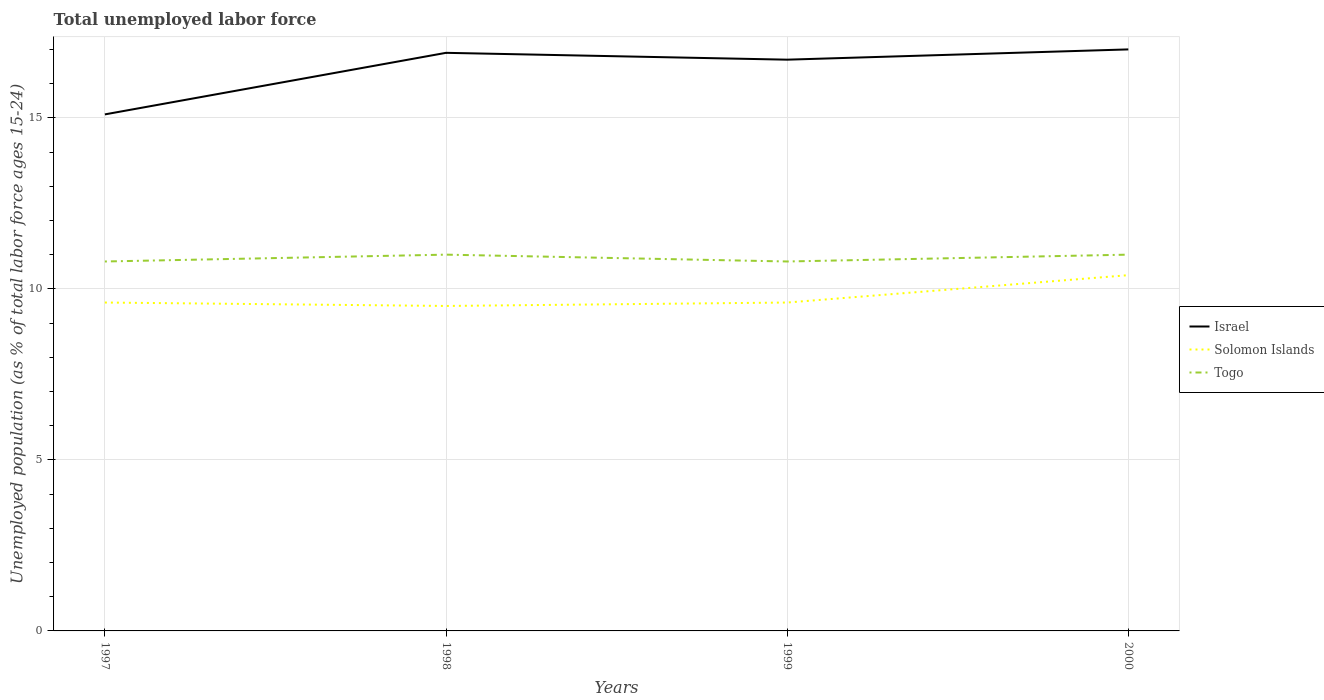How many different coloured lines are there?
Keep it short and to the point. 3. Does the line corresponding to Solomon Islands intersect with the line corresponding to Israel?
Your answer should be compact. No. Is the number of lines equal to the number of legend labels?
Provide a short and direct response. Yes. Across all years, what is the maximum percentage of unemployed population in in Israel?
Keep it short and to the point. 15.1. What is the total percentage of unemployed population in in Solomon Islands in the graph?
Provide a short and direct response. -0.8. What is the difference between the highest and the second highest percentage of unemployed population in in Solomon Islands?
Keep it short and to the point. 0.9. What is the difference between the highest and the lowest percentage of unemployed population in in Israel?
Ensure brevity in your answer.  3. Is the percentage of unemployed population in in Israel strictly greater than the percentage of unemployed population in in Solomon Islands over the years?
Provide a succinct answer. No. How many lines are there?
Make the answer very short. 3. Are the values on the major ticks of Y-axis written in scientific E-notation?
Your answer should be very brief. No. Does the graph contain grids?
Your answer should be very brief. Yes. Where does the legend appear in the graph?
Your answer should be very brief. Center right. How many legend labels are there?
Give a very brief answer. 3. How are the legend labels stacked?
Your answer should be very brief. Vertical. What is the title of the graph?
Give a very brief answer. Total unemployed labor force. Does "Upper middle income" appear as one of the legend labels in the graph?
Provide a short and direct response. No. What is the label or title of the Y-axis?
Offer a very short reply. Unemployed population (as % of total labor force ages 15-24). What is the Unemployed population (as % of total labor force ages 15-24) in Israel in 1997?
Your answer should be compact. 15.1. What is the Unemployed population (as % of total labor force ages 15-24) of Solomon Islands in 1997?
Your answer should be compact. 9.6. What is the Unemployed population (as % of total labor force ages 15-24) of Togo in 1997?
Offer a very short reply. 10.8. What is the Unemployed population (as % of total labor force ages 15-24) of Israel in 1998?
Your answer should be very brief. 16.9. What is the Unemployed population (as % of total labor force ages 15-24) of Solomon Islands in 1998?
Your answer should be compact. 9.5. What is the Unemployed population (as % of total labor force ages 15-24) of Israel in 1999?
Offer a very short reply. 16.7. What is the Unemployed population (as % of total labor force ages 15-24) of Solomon Islands in 1999?
Make the answer very short. 9.6. What is the Unemployed population (as % of total labor force ages 15-24) of Togo in 1999?
Your answer should be compact. 10.8. What is the Unemployed population (as % of total labor force ages 15-24) of Israel in 2000?
Offer a very short reply. 17. What is the Unemployed population (as % of total labor force ages 15-24) of Solomon Islands in 2000?
Keep it short and to the point. 10.4. Across all years, what is the maximum Unemployed population (as % of total labor force ages 15-24) in Solomon Islands?
Offer a very short reply. 10.4. Across all years, what is the maximum Unemployed population (as % of total labor force ages 15-24) of Togo?
Provide a short and direct response. 11. Across all years, what is the minimum Unemployed population (as % of total labor force ages 15-24) in Israel?
Make the answer very short. 15.1. Across all years, what is the minimum Unemployed population (as % of total labor force ages 15-24) in Togo?
Your response must be concise. 10.8. What is the total Unemployed population (as % of total labor force ages 15-24) of Israel in the graph?
Give a very brief answer. 65.7. What is the total Unemployed population (as % of total labor force ages 15-24) of Solomon Islands in the graph?
Give a very brief answer. 39.1. What is the total Unemployed population (as % of total labor force ages 15-24) of Togo in the graph?
Your answer should be compact. 43.6. What is the difference between the Unemployed population (as % of total labor force ages 15-24) in Israel in 1997 and that in 1998?
Ensure brevity in your answer.  -1.8. What is the difference between the Unemployed population (as % of total labor force ages 15-24) in Solomon Islands in 1997 and that in 1998?
Keep it short and to the point. 0.1. What is the difference between the Unemployed population (as % of total labor force ages 15-24) of Togo in 1997 and that in 1998?
Make the answer very short. -0.2. What is the difference between the Unemployed population (as % of total labor force ages 15-24) in Togo in 1997 and that in 1999?
Ensure brevity in your answer.  0. What is the difference between the Unemployed population (as % of total labor force ages 15-24) of Solomon Islands in 1997 and that in 2000?
Your answer should be very brief. -0.8. What is the difference between the Unemployed population (as % of total labor force ages 15-24) in Togo in 1997 and that in 2000?
Provide a short and direct response. -0.2. What is the difference between the Unemployed population (as % of total labor force ages 15-24) in Togo in 1998 and that in 1999?
Keep it short and to the point. 0.2. What is the difference between the Unemployed population (as % of total labor force ages 15-24) of Solomon Islands in 1998 and that in 2000?
Ensure brevity in your answer.  -0.9. What is the difference between the Unemployed population (as % of total labor force ages 15-24) in Israel in 1997 and the Unemployed population (as % of total labor force ages 15-24) in Solomon Islands in 1998?
Ensure brevity in your answer.  5.6. What is the difference between the Unemployed population (as % of total labor force ages 15-24) of Israel in 1997 and the Unemployed population (as % of total labor force ages 15-24) of Solomon Islands in 1999?
Your answer should be compact. 5.5. What is the difference between the Unemployed population (as % of total labor force ages 15-24) of Solomon Islands in 1997 and the Unemployed population (as % of total labor force ages 15-24) of Togo in 1999?
Provide a short and direct response. -1.2. What is the difference between the Unemployed population (as % of total labor force ages 15-24) in Israel in 1997 and the Unemployed population (as % of total labor force ages 15-24) in Togo in 2000?
Provide a succinct answer. 4.1. What is the difference between the Unemployed population (as % of total labor force ages 15-24) of Israel in 1998 and the Unemployed population (as % of total labor force ages 15-24) of Solomon Islands in 1999?
Give a very brief answer. 7.3. What is the difference between the Unemployed population (as % of total labor force ages 15-24) in Israel in 1998 and the Unemployed population (as % of total labor force ages 15-24) in Togo in 1999?
Keep it short and to the point. 6.1. What is the difference between the Unemployed population (as % of total labor force ages 15-24) of Israel in 1998 and the Unemployed population (as % of total labor force ages 15-24) of Togo in 2000?
Give a very brief answer. 5.9. What is the difference between the Unemployed population (as % of total labor force ages 15-24) of Solomon Islands in 1998 and the Unemployed population (as % of total labor force ages 15-24) of Togo in 2000?
Make the answer very short. -1.5. What is the difference between the Unemployed population (as % of total labor force ages 15-24) in Israel in 1999 and the Unemployed population (as % of total labor force ages 15-24) in Solomon Islands in 2000?
Make the answer very short. 6.3. What is the average Unemployed population (as % of total labor force ages 15-24) of Israel per year?
Keep it short and to the point. 16.43. What is the average Unemployed population (as % of total labor force ages 15-24) of Solomon Islands per year?
Ensure brevity in your answer.  9.78. In the year 1997, what is the difference between the Unemployed population (as % of total labor force ages 15-24) of Israel and Unemployed population (as % of total labor force ages 15-24) of Solomon Islands?
Offer a terse response. 5.5. In the year 1999, what is the difference between the Unemployed population (as % of total labor force ages 15-24) in Solomon Islands and Unemployed population (as % of total labor force ages 15-24) in Togo?
Provide a short and direct response. -1.2. In the year 2000, what is the difference between the Unemployed population (as % of total labor force ages 15-24) of Solomon Islands and Unemployed population (as % of total labor force ages 15-24) of Togo?
Ensure brevity in your answer.  -0.6. What is the ratio of the Unemployed population (as % of total labor force ages 15-24) in Israel in 1997 to that in 1998?
Give a very brief answer. 0.89. What is the ratio of the Unemployed population (as % of total labor force ages 15-24) in Solomon Islands in 1997 to that in 1998?
Offer a very short reply. 1.01. What is the ratio of the Unemployed population (as % of total labor force ages 15-24) in Togo in 1997 to that in 1998?
Ensure brevity in your answer.  0.98. What is the ratio of the Unemployed population (as % of total labor force ages 15-24) in Israel in 1997 to that in 1999?
Your response must be concise. 0.9. What is the ratio of the Unemployed population (as % of total labor force ages 15-24) in Israel in 1997 to that in 2000?
Ensure brevity in your answer.  0.89. What is the ratio of the Unemployed population (as % of total labor force ages 15-24) in Togo in 1997 to that in 2000?
Give a very brief answer. 0.98. What is the ratio of the Unemployed population (as % of total labor force ages 15-24) of Israel in 1998 to that in 1999?
Offer a terse response. 1.01. What is the ratio of the Unemployed population (as % of total labor force ages 15-24) of Solomon Islands in 1998 to that in 1999?
Your answer should be very brief. 0.99. What is the ratio of the Unemployed population (as % of total labor force ages 15-24) of Togo in 1998 to that in 1999?
Your answer should be compact. 1.02. What is the ratio of the Unemployed population (as % of total labor force ages 15-24) in Israel in 1998 to that in 2000?
Keep it short and to the point. 0.99. What is the ratio of the Unemployed population (as % of total labor force ages 15-24) in Solomon Islands in 1998 to that in 2000?
Ensure brevity in your answer.  0.91. What is the ratio of the Unemployed population (as % of total labor force ages 15-24) in Israel in 1999 to that in 2000?
Offer a very short reply. 0.98. What is the ratio of the Unemployed population (as % of total labor force ages 15-24) in Solomon Islands in 1999 to that in 2000?
Provide a succinct answer. 0.92. What is the ratio of the Unemployed population (as % of total labor force ages 15-24) of Togo in 1999 to that in 2000?
Your answer should be very brief. 0.98. What is the difference between the highest and the second highest Unemployed population (as % of total labor force ages 15-24) in Israel?
Offer a very short reply. 0.1. What is the difference between the highest and the second highest Unemployed population (as % of total labor force ages 15-24) of Solomon Islands?
Offer a very short reply. 0.8. What is the difference between the highest and the second highest Unemployed population (as % of total labor force ages 15-24) in Togo?
Give a very brief answer. 0. What is the difference between the highest and the lowest Unemployed population (as % of total labor force ages 15-24) in Israel?
Ensure brevity in your answer.  1.9. What is the difference between the highest and the lowest Unemployed population (as % of total labor force ages 15-24) in Solomon Islands?
Make the answer very short. 0.9. What is the difference between the highest and the lowest Unemployed population (as % of total labor force ages 15-24) in Togo?
Give a very brief answer. 0.2. 